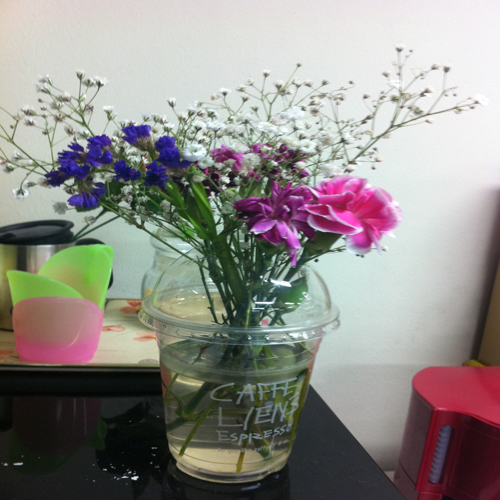Aside from the bouquet, what does the background tell us about the setting? The background contains office-related items like a pink stapler and a binder clip, which could indicate the bouquet is placed on a desk at a workplace. The objects around it suggest a functional space that has been brightened by the presence of flowers. 